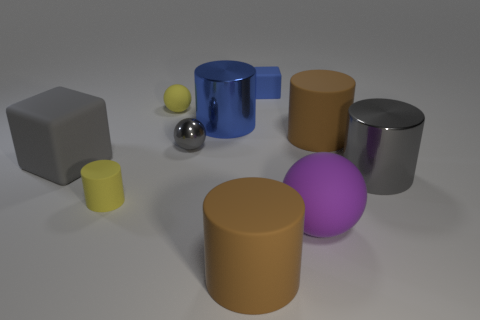Subtract 1 cylinders. How many cylinders are left? 4 Subtract all big gray shiny cylinders. How many cylinders are left? 4 Subtract all yellow cylinders. How many cylinders are left? 4 Subtract all green cylinders. Subtract all yellow cubes. How many cylinders are left? 5 Subtract all spheres. How many objects are left? 7 Subtract all large purple matte things. Subtract all small metallic things. How many objects are left? 8 Add 4 big blocks. How many big blocks are left? 5 Add 5 big matte things. How many big matte things exist? 9 Subtract 0 red balls. How many objects are left? 10 